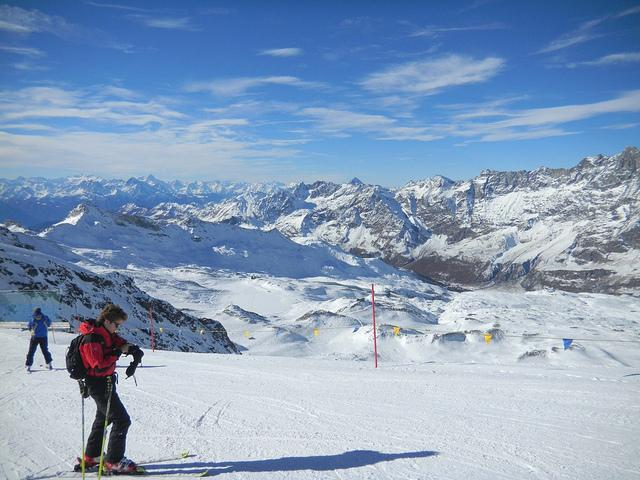Where is the sun with respect to the person wearing red coat? Please explain your reasoning. back. The sun is behind the man with the coat given his shadow. 